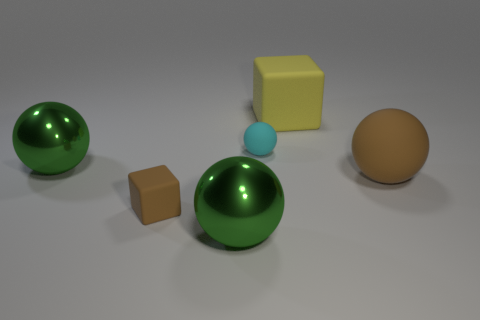Subtract all large rubber spheres. How many spheres are left? 3 Subtract all green balls. How many balls are left? 2 Add 1 large green objects. How many objects exist? 7 Subtract all spheres. How many objects are left? 2 Subtract 2 cubes. How many cubes are left? 0 Subtract all yellow blocks. Subtract all purple balls. How many blocks are left? 1 Subtract all red blocks. How many cyan balls are left? 1 Subtract all large cubes. Subtract all large shiny spheres. How many objects are left? 3 Add 2 large green shiny balls. How many large green shiny balls are left? 4 Add 5 yellow things. How many yellow things exist? 6 